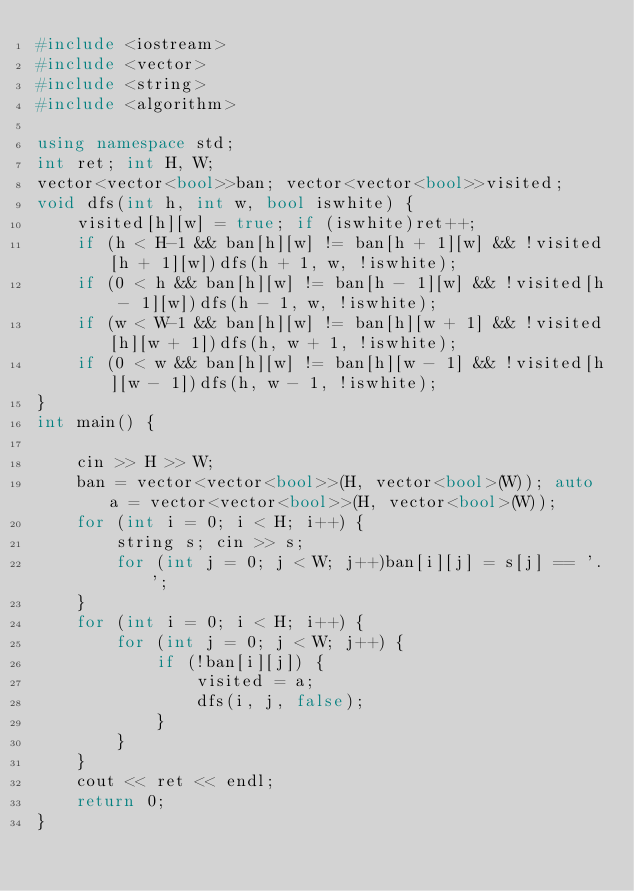<code> <loc_0><loc_0><loc_500><loc_500><_C++_>#include <iostream>
#include <vector>
#include <string>
#include <algorithm>

using namespace std;
int ret; int H, W;
vector<vector<bool>>ban; vector<vector<bool>>visited;
void dfs(int h, int w, bool iswhite) {
	visited[h][w] = true; if (iswhite)ret++;
	if (h < H-1 && ban[h][w] != ban[h + 1][w] && !visited[h + 1][w])dfs(h + 1, w, !iswhite);
	if (0 < h && ban[h][w] != ban[h - 1][w] && !visited[h - 1][w])dfs(h - 1, w, !iswhite);
	if (w < W-1 && ban[h][w] != ban[h][w + 1] && !visited[h][w + 1])dfs(h, w + 1, !iswhite);
	if (0 < w && ban[h][w] != ban[h][w - 1] && !visited[h][w - 1])dfs(h, w - 1, !iswhite);
}
int main() {

	cin >> H >> W;
	ban = vector<vector<bool>>(H, vector<bool>(W)); auto a = vector<vector<bool>>(H, vector<bool>(W));
	for (int i = 0; i < H; i++) {
		string s; cin >> s;
		for (int j = 0; j < W; j++)ban[i][j] = s[j] == '.';
	}
	for (int i = 0; i < H; i++) {
		for (int j = 0; j < W; j++) {
			if (!ban[i][j]) {
				visited = a;
				dfs(i, j, false);
			}
		}
	}
	cout << ret << endl;
	return 0;
}</code> 